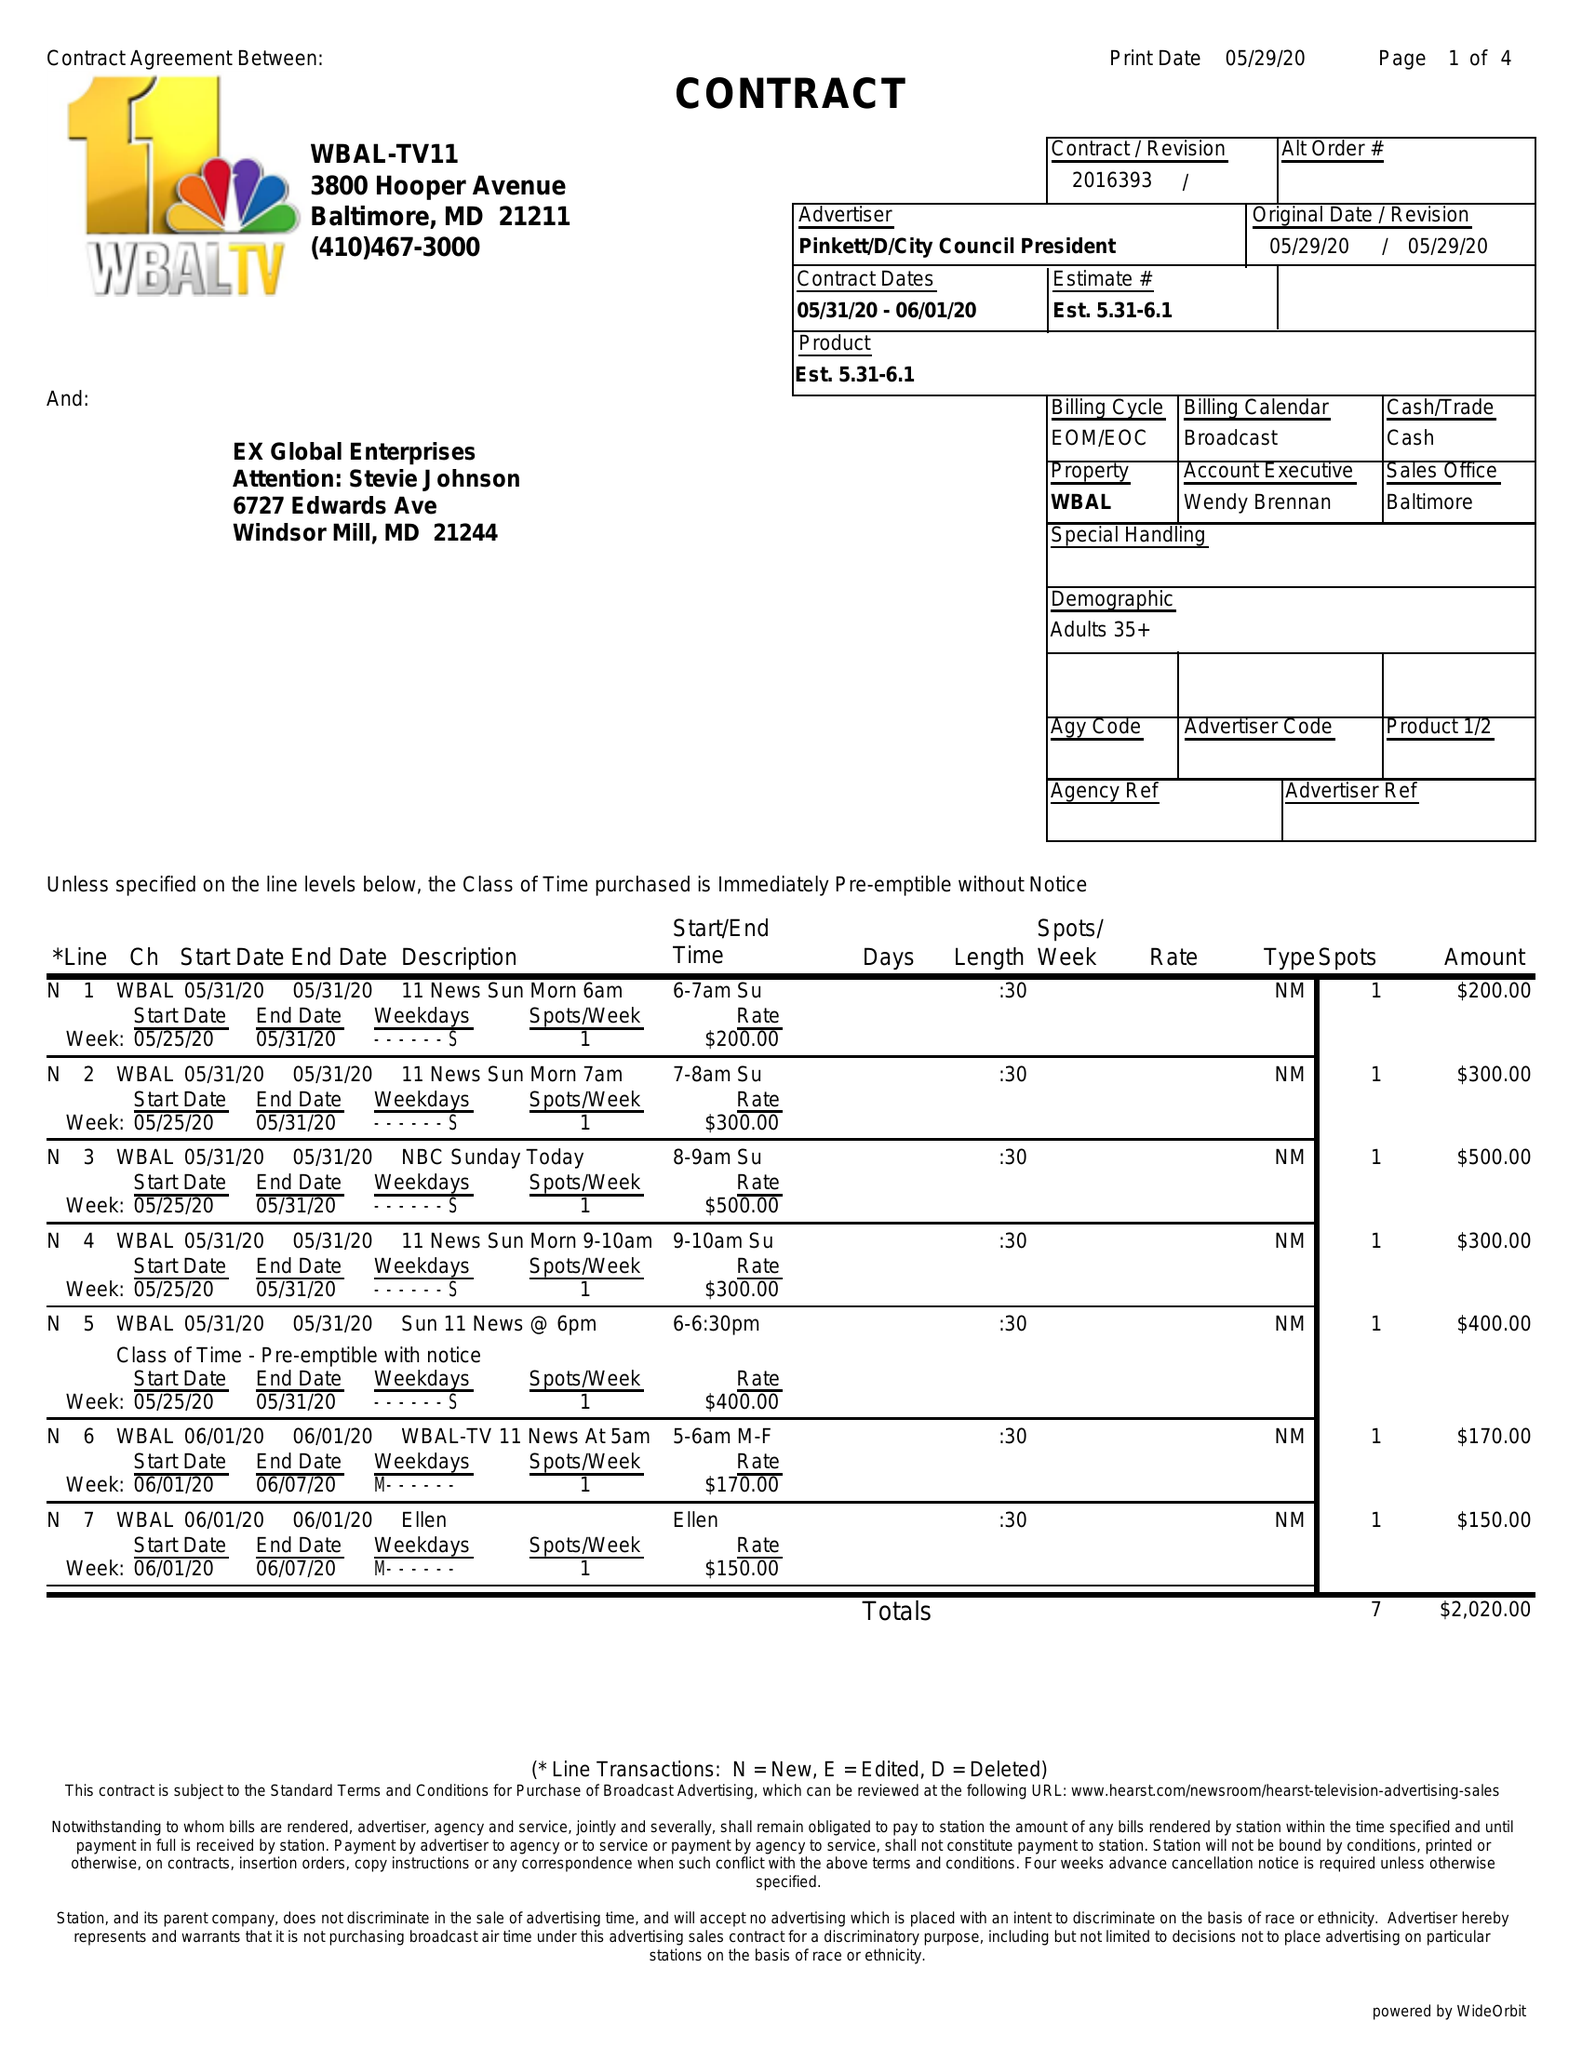What is the value for the flight_to?
Answer the question using a single word or phrase. 06/01/20 